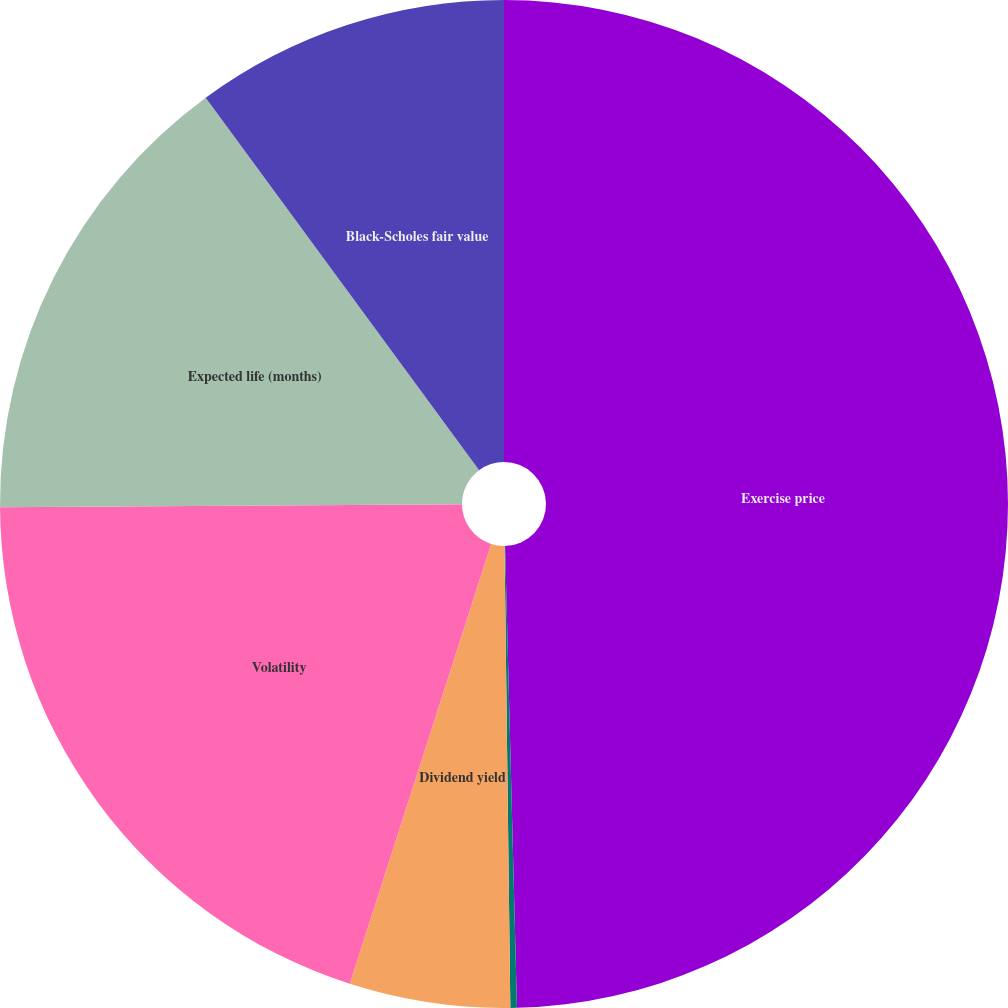<chart> <loc_0><loc_0><loc_500><loc_500><pie_chart><fcel>Exercise price<fcel>Risk-free interest rate<fcel>Dividend yield<fcel>Volatility<fcel>Expected life (months)<fcel>Black-Scholes fair value<nl><fcel>49.59%<fcel>0.21%<fcel>5.15%<fcel>19.95%<fcel>15.02%<fcel>10.08%<nl></chart> 